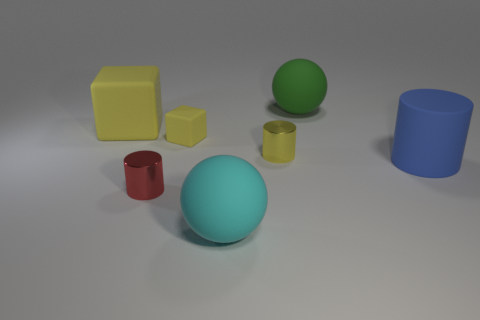How many cyan rubber spheres have the same size as the red metallic object?
Your answer should be very brief. 0. There is a big thing in front of the large rubber cylinder; is it the same shape as the green matte thing to the right of the red cylinder?
Your answer should be very brief. Yes. What is the shape of the metallic object that is the same color as the large block?
Your answer should be very brief. Cylinder. There is a tiny shiny cylinder that is to the left of the metallic cylinder behind the large blue cylinder; what color is it?
Offer a terse response. Red. There is another metallic thing that is the same shape as the small red object; what color is it?
Offer a very short reply. Yellow. There is a green object that is the same shape as the cyan rubber object; what size is it?
Keep it short and to the point. Large. What is the large object that is in front of the large cylinder made of?
Your answer should be very brief. Rubber. Are there fewer red metal objects behind the green thing than big things?
Provide a short and direct response. Yes. There is a tiny shiny thing that is left of the big rubber thing that is in front of the red metallic cylinder; what is its shape?
Your response must be concise. Cylinder. The tiny matte object is what color?
Make the answer very short. Yellow. 